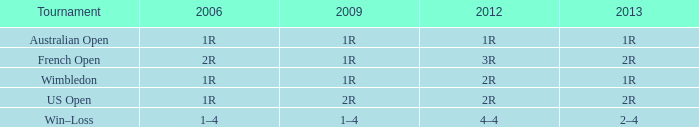What is the Tournament when the 2013 is 2r, and a 2006 is 1r? US Open. 